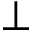<formula> <loc_0><loc_0><loc_500><loc_500>\perp</formula> 